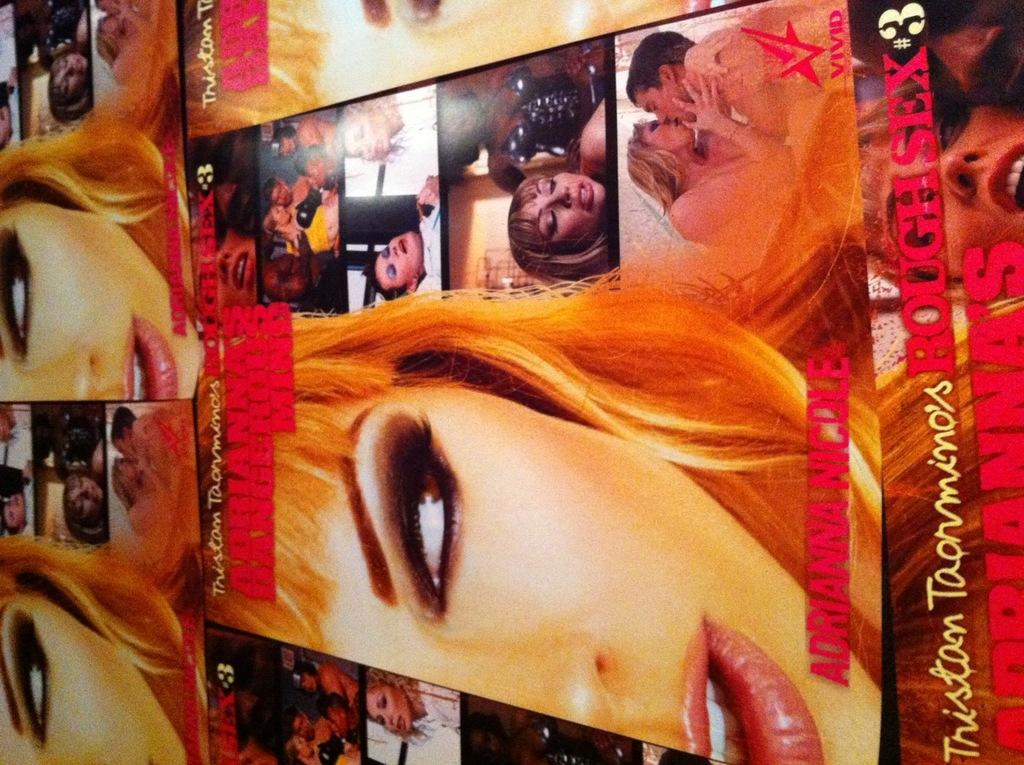<image>
Render a clear and concise summary of the photo. Picture showing a woman and man making out and the number 3 on the bottom. 